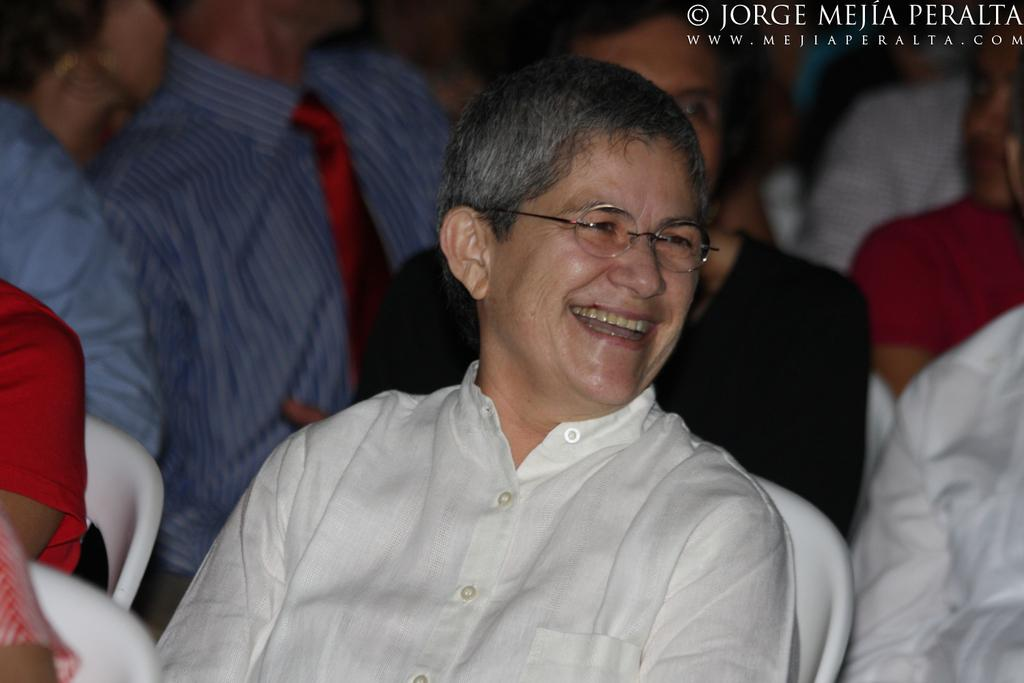What are the people in the image doing? The people in the image are sitting on chairs. Can you describe the text in the image? There is text in the top right corner of the image. What type of plough is being used by the people in the image? There is no plough present in the image; it features people sitting on chairs. How does the behavior of the people in the image change throughout the day? The provided facts do not give information about the behavior of the people in the image or how it changes throughout the day. 